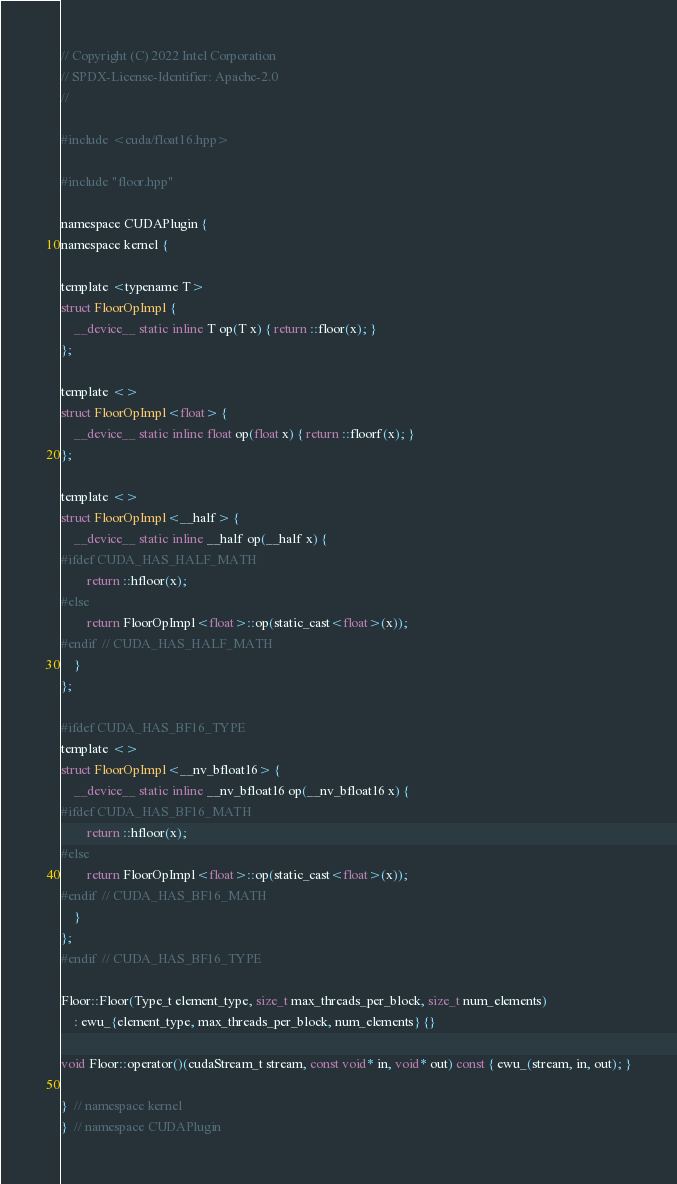<code> <loc_0><loc_0><loc_500><loc_500><_Cuda_>// Copyright (C) 2022 Intel Corporation
// SPDX-License-Identifier: Apache-2.0
//

#include <cuda/float16.hpp>

#include "floor.hpp"

namespace CUDAPlugin {
namespace kernel {

template <typename T>
struct FloorOpImpl {
    __device__ static inline T op(T x) { return ::floor(x); }
};

template <>
struct FloorOpImpl<float> {
    __device__ static inline float op(float x) { return ::floorf(x); }
};

template <>
struct FloorOpImpl<__half> {
    __device__ static inline __half op(__half x) {
#ifdef CUDA_HAS_HALF_MATH
        return ::hfloor(x);
#else
        return FloorOpImpl<float>::op(static_cast<float>(x));
#endif  // CUDA_HAS_HALF_MATH
    }
};

#ifdef CUDA_HAS_BF16_TYPE
template <>
struct FloorOpImpl<__nv_bfloat16> {
    __device__ static inline __nv_bfloat16 op(__nv_bfloat16 x) {
#ifdef CUDA_HAS_BF16_MATH
        return ::hfloor(x);
#else
        return FloorOpImpl<float>::op(static_cast<float>(x));
#endif  // CUDA_HAS_BF16_MATH
    }
};
#endif  // CUDA_HAS_BF16_TYPE

Floor::Floor(Type_t element_type, size_t max_threads_per_block, size_t num_elements)
    : ewu_{element_type, max_threads_per_block, num_elements} {}

void Floor::operator()(cudaStream_t stream, const void* in, void* out) const { ewu_(stream, in, out); }

}  // namespace kernel
}  // namespace CUDAPlugin
</code> 